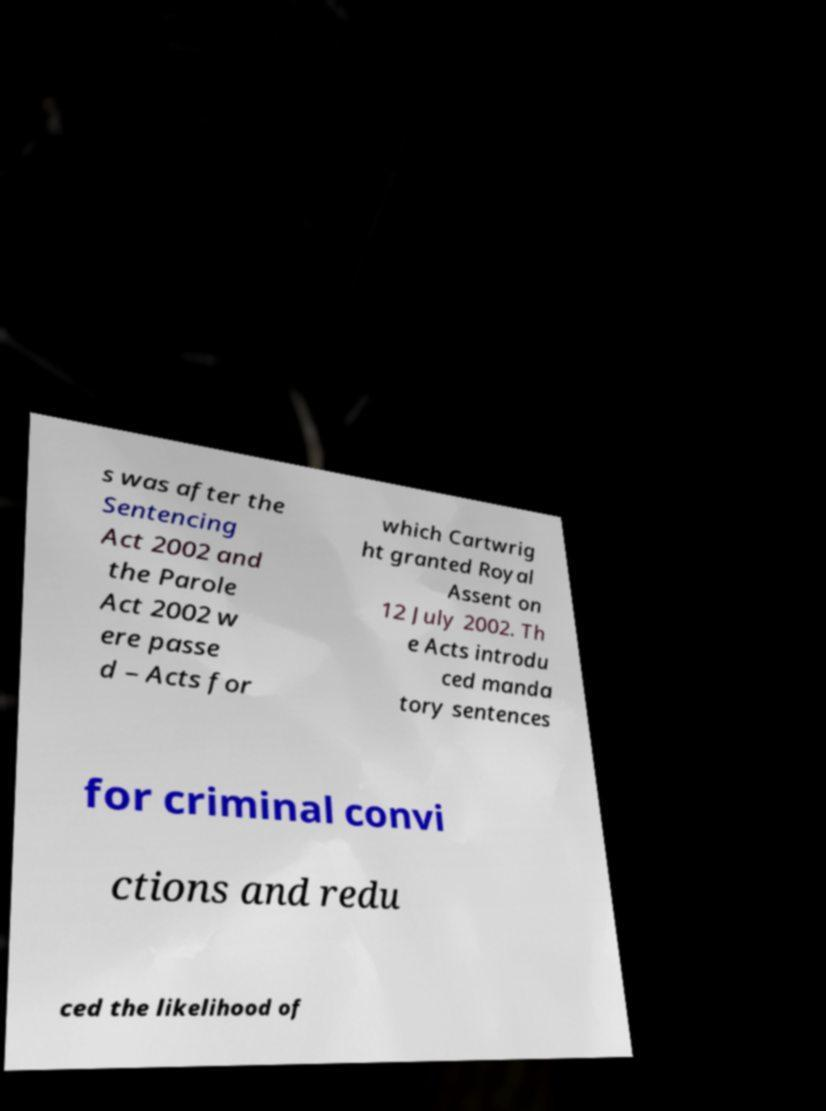There's text embedded in this image that I need extracted. Can you transcribe it verbatim? s was after the Sentencing Act 2002 and the Parole Act 2002 w ere passe d – Acts for which Cartwrig ht granted Royal Assent on 12 July 2002. Th e Acts introdu ced manda tory sentences for criminal convi ctions and redu ced the likelihood of 